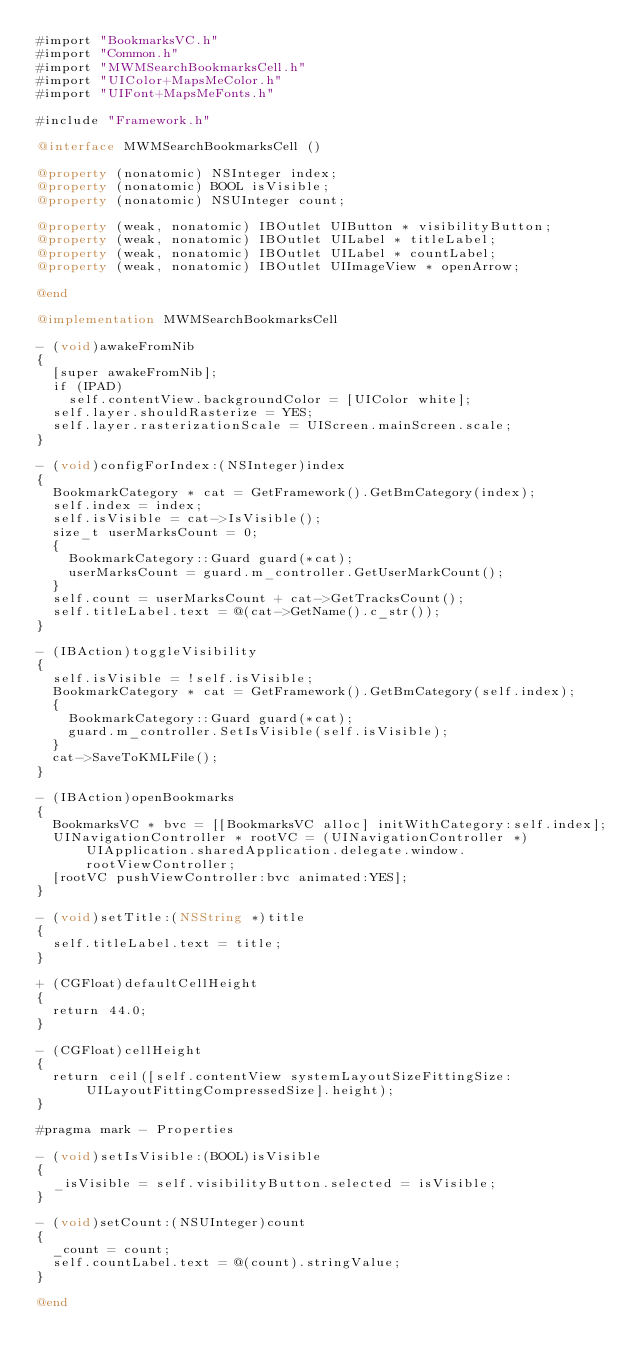Convert code to text. <code><loc_0><loc_0><loc_500><loc_500><_ObjectiveC_>#import "BookmarksVC.h"
#import "Common.h"
#import "MWMSearchBookmarksCell.h"
#import "UIColor+MapsMeColor.h"
#import "UIFont+MapsMeFonts.h"

#include "Framework.h"

@interface MWMSearchBookmarksCell ()

@property (nonatomic) NSInteger index;
@property (nonatomic) BOOL isVisible;
@property (nonatomic) NSUInteger count;

@property (weak, nonatomic) IBOutlet UIButton * visibilityButton;
@property (weak, nonatomic) IBOutlet UILabel * titleLabel;
@property (weak, nonatomic) IBOutlet UILabel * countLabel;
@property (weak, nonatomic) IBOutlet UIImageView * openArrow;

@end

@implementation MWMSearchBookmarksCell

- (void)awakeFromNib
{
  [super awakeFromNib];
  if (IPAD)
    self.contentView.backgroundColor = [UIColor white];
  self.layer.shouldRasterize = YES;
  self.layer.rasterizationScale = UIScreen.mainScreen.scale;
}

- (void)configForIndex:(NSInteger)index
{
  BookmarkCategory * cat = GetFramework().GetBmCategory(index);
  self.index = index;
  self.isVisible = cat->IsVisible();
  size_t userMarksCount = 0;
  {
    BookmarkCategory::Guard guard(*cat);
    userMarksCount = guard.m_controller.GetUserMarkCount();
  }
  self.count = userMarksCount + cat->GetTracksCount();
  self.titleLabel.text = @(cat->GetName().c_str());
}

- (IBAction)toggleVisibility
{
  self.isVisible = !self.isVisible;
  BookmarkCategory * cat = GetFramework().GetBmCategory(self.index);
  {
    BookmarkCategory::Guard guard(*cat);
    guard.m_controller.SetIsVisible(self.isVisible);
  }
  cat->SaveToKMLFile();
}

- (IBAction)openBookmarks
{
  BookmarksVC * bvc = [[BookmarksVC alloc] initWithCategory:self.index];
  UINavigationController * rootVC = (UINavigationController *)UIApplication.sharedApplication.delegate.window.rootViewController;
  [rootVC pushViewController:bvc animated:YES];
}

- (void)setTitle:(NSString *)title
{
  self.titleLabel.text = title;
}

+ (CGFloat)defaultCellHeight
{
  return 44.0;
}

- (CGFloat)cellHeight
{
  return ceil([self.contentView systemLayoutSizeFittingSize:UILayoutFittingCompressedSize].height);
}

#pragma mark - Properties

- (void)setIsVisible:(BOOL)isVisible
{
  _isVisible = self.visibilityButton.selected = isVisible;
}

- (void)setCount:(NSUInteger)count
{
  _count = count;
  self.countLabel.text = @(count).stringValue;
}

@end
</code> 